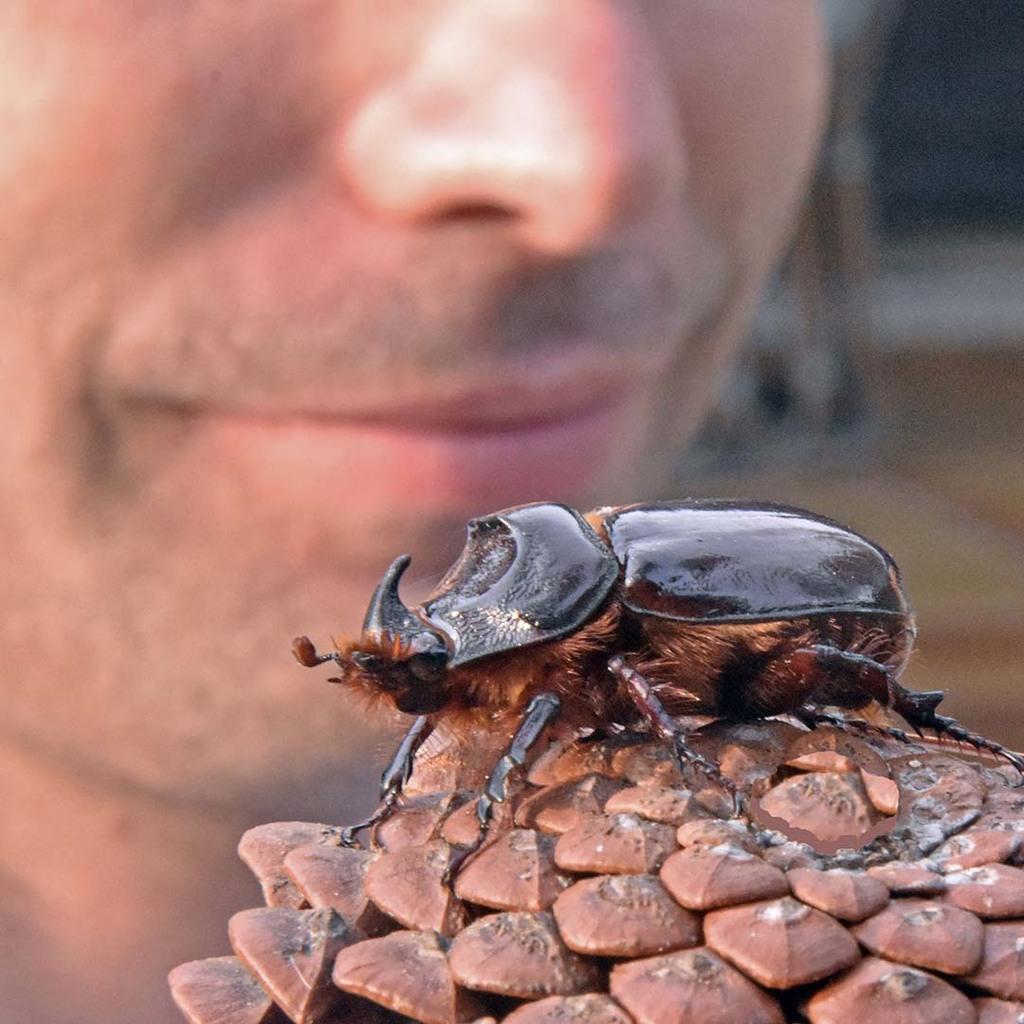Can you describe this image briefly? In this image I can see the insect in brown and black color on the brown color object. In the background I can see the person face. 